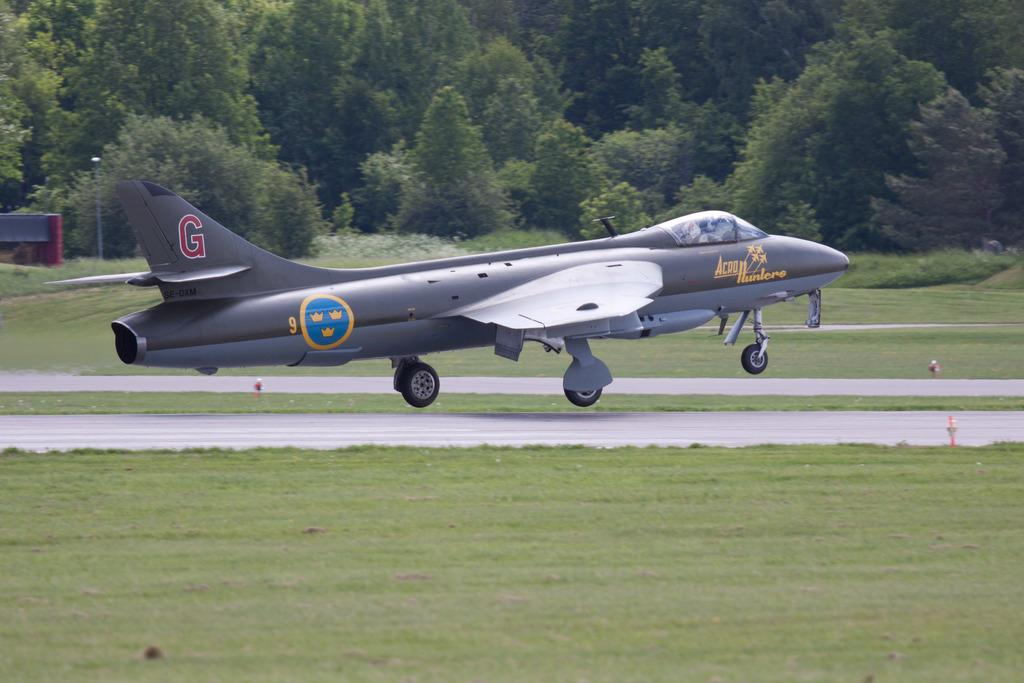<image>
Present a compact description of the photo's key features. An airplane with the letter G written on the tail 